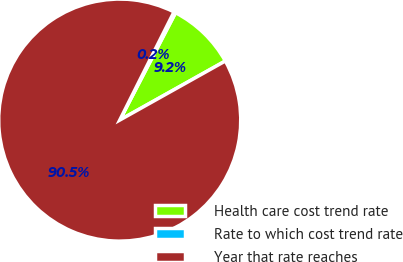Convert chart to OTSL. <chart><loc_0><loc_0><loc_500><loc_500><pie_chart><fcel>Health care cost trend rate<fcel>Rate to which cost trend rate<fcel>Year that rate reaches<nl><fcel>9.25%<fcel>0.23%<fcel>90.52%<nl></chart> 